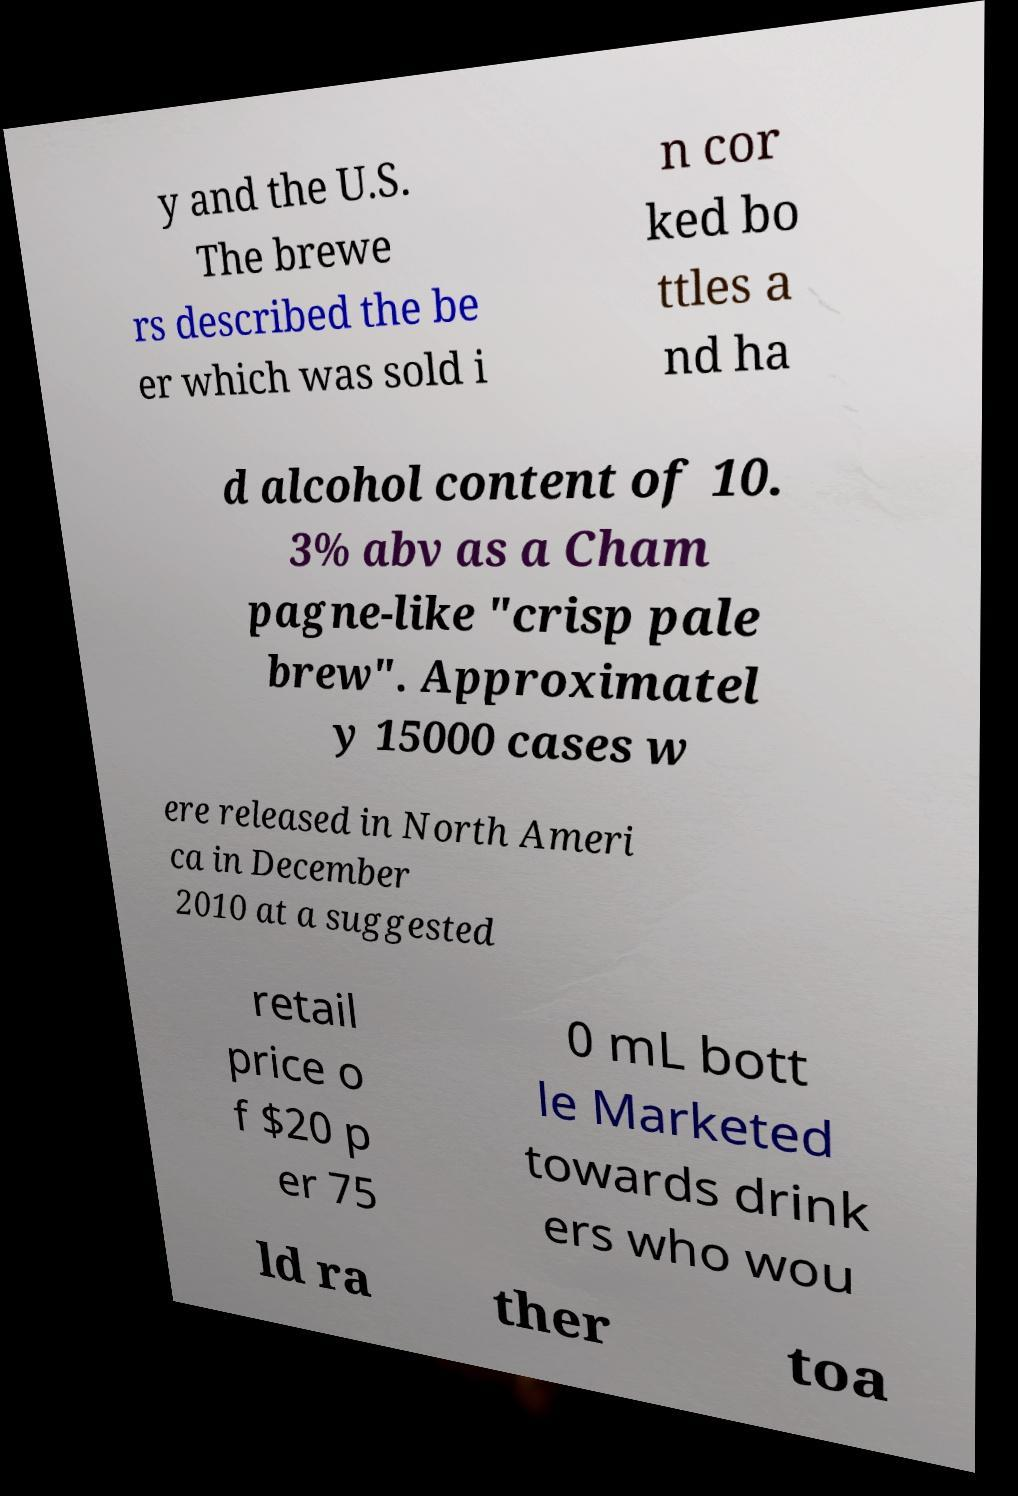Please read and relay the text visible in this image. What does it say? y and the U.S. The brewe rs described the be er which was sold i n cor ked bo ttles a nd ha d alcohol content of 10. 3% abv as a Cham pagne-like "crisp pale brew". Approximatel y 15000 cases w ere released in North Ameri ca in December 2010 at a suggested retail price o f $20 p er 75 0 mL bott le Marketed towards drink ers who wou ld ra ther toa 